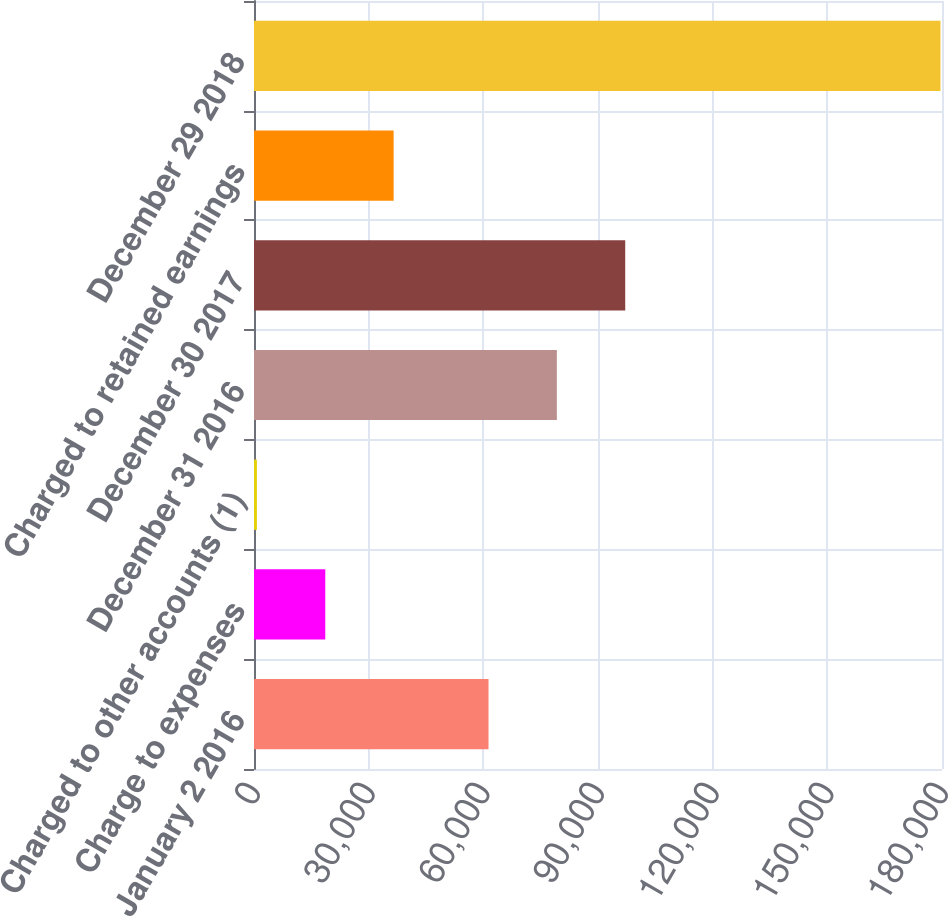Convert chart to OTSL. <chart><loc_0><loc_0><loc_500><loc_500><bar_chart><fcel>January 2 2016<fcel>Charge to expenses<fcel>Charged to other accounts (1)<fcel>December 31 2016<fcel>December 30 2017<fcel>Charged to retained earnings<fcel>December 29 2018<nl><fcel>61358<fcel>18649.3<fcel>766<fcel>79241.3<fcel>97124.6<fcel>36532.6<fcel>179599<nl></chart> 